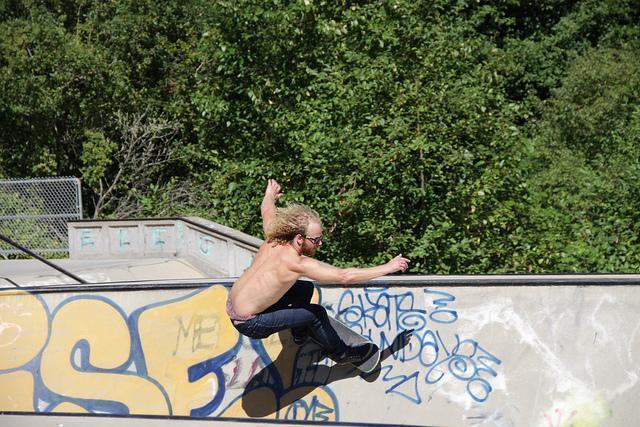How many giraffes are in the scene?
Give a very brief answer. 0. 